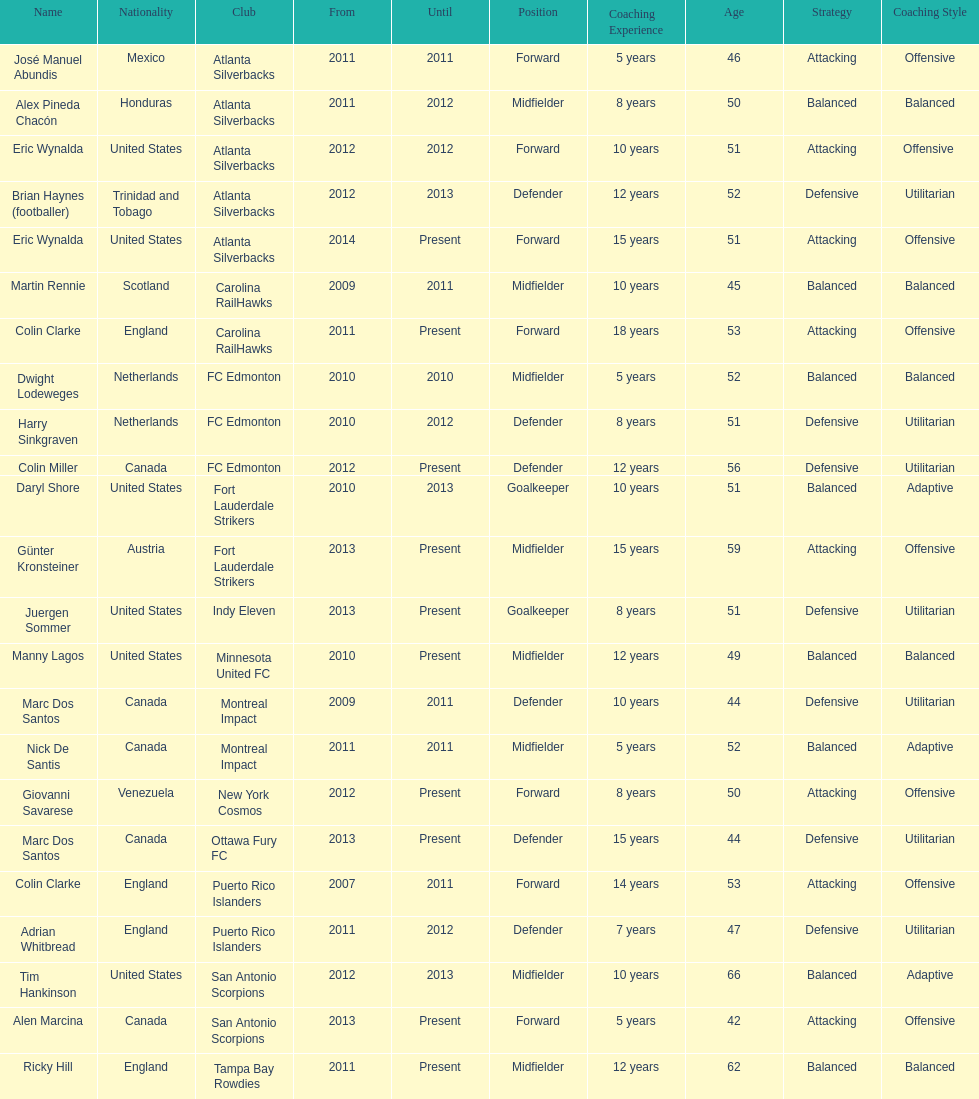What same country did marc dos santos coach as colin miller? Canada. 